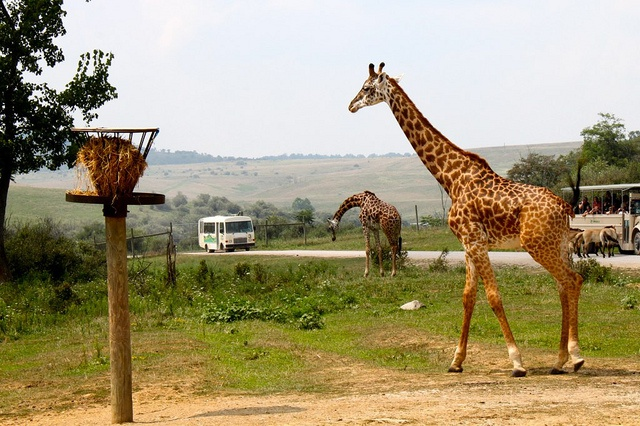Describe the objects in this image and their specific colors. I can see giraffe in black, brown, maroon, and tan tones, giraffe in black, olive, maroon, and gray tones, truck in black, gray, darkgreen, and tan tones, bus in black, tan, and gray tones, and truck in black, ivory, gray, and darkgray tones in this image. 